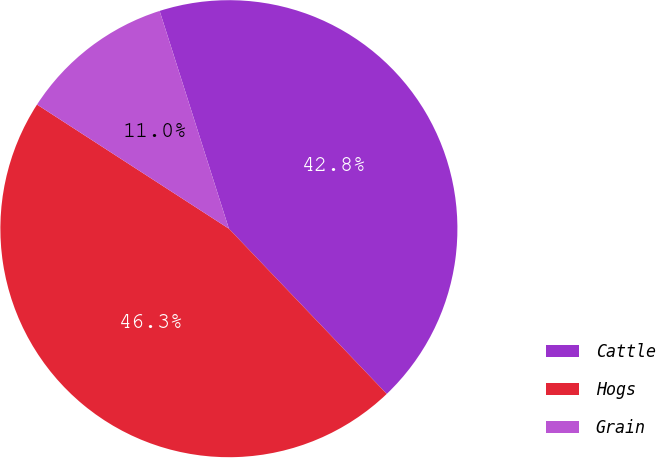Convert chart to OTSL. <chart><loc_0><loc_0><loc_500><loc_500><pie_chart><fcel>Cattle<fcel>Hogs<fcel>Grain<nl><fcel>42.76%<fcel>46.27%<fcel>10.96%<nl></chart> 